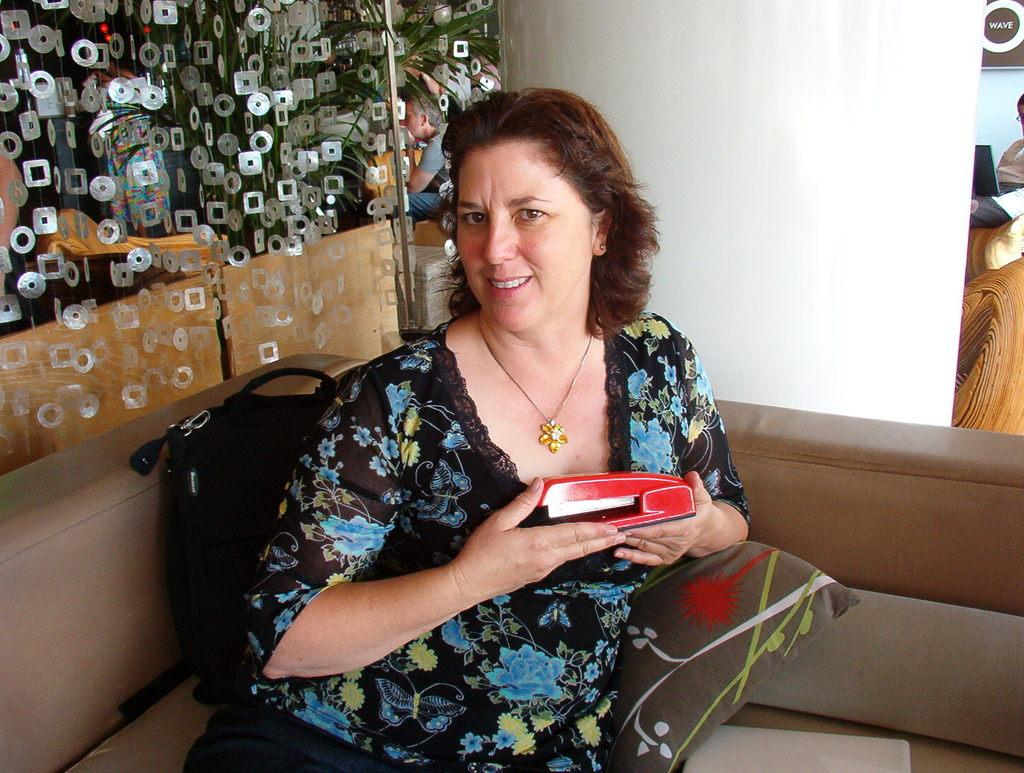Who is present in the image? There is a woman in the image. What is the woman doing in the image? The woman is sitting on a sofa and smiling. What objects are beside the woman? There is a bag and a pillow beside the woman. What can be seen in the background of the image? There are plants and people in the background of the image. What type of tools does the carpenter use in the image? There is no carpenter present in the image, so no tools can be observed. What is the tendency of the ball in the image? There is no ball present in the image, so no tendency can be determined. 